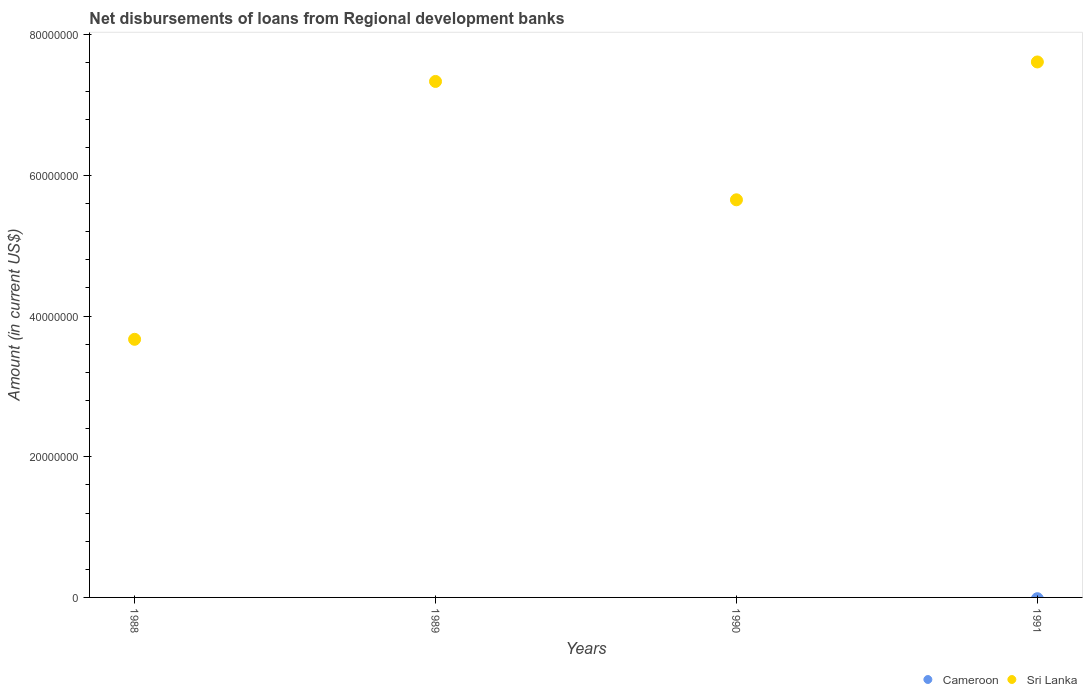What is the amount of disbursements of loans from regional development banks in Sri Lanka in 1990?
Provide a short and direct response. 5.65e+07. Across all years, what is the maximum amount of disbursements of loans from regional development banks in Sri Lanka?
Your answer should be very brief. 7.61e+07. Across all years, what is the minimum amount of disbursements of loans from regional development banks in Sri Lanka?
Your answer should be compact. 3.67e+07. What is the total amount of disbursements of loans from regional development banks in Sri Lanka in the graph?
Provide a succinct answer. 2.43e+08. What is the difference between the amount of disbursements of loans from regional development banks in Sri Lanka in 1989 and that in 1991?
Keep it short and to the point. -2.77e+06. What is the difference between the amount of disbursements of loans from regional development banks in Sri Lanka in 1988 and the amount of disbursements of loans from regional development banks in Cameroon in 1989?
Provide a short and direct response. 3.67e+07. What is the average amount of disbursements of loans from regional development banks in Sri Lanka per year?
Ensure brevity in your answer.  6.07e+07. What is the ratio of the amount of disbursements of loans from regional development banks in Sri Lanka in 1989 to that in 1991?
Offer a terse response. 0.96. Is the amount of disbursements of loans from regional development banks in Sri Lanka in 1990 less than that in 1991?
Offer a very short reply. Yes. What is the difference between the highest and the second highest amount of disbursements of loans from regional development banks in Sri Lanka?
Keep it short and to the point. 2.77e+06. What is the difference between the highest and the lowest amount of disbursements of loans from regional development banks in Sri Lanka?
Keep it short and to the point. 3.94e+07. In how many years, is the amount of disbursements of loans from regional development banks in Sri Lanka greater than the average amount of disbursements of loans from regional development banks in Sri Lanka taken over all years?
Provide a succinct answer. 2. Is the sum of the amount of disbursements of loans from regional development banks in Sri Lanka in 1988 and 1989 greater than the maximum amount of disbursements of loans from regional development banks in Cameroon across all years?
Provide a short and direct response. Yes. Is the amount of disbursements of loans from regional development banks in Cameroon strictly greater than the amount of disbursements of loans from regional development banks in Sri Lanka over the years?
Your answer should be very brief. No. How many dotlines are there?
Your answer should be very brief. 1. How many years are there in the graph?
Your answer should be compact. 4. What is the difference between two consecutive major ticks on the Y-axis?
Give a very brief answer. 2.00e+07. Does the graph contain grids?
Provide a short and direct response. No. Where does the legend appear in the graph?
Make the answer very short. Bottom right. How are the legend labels stacked?
Keep it short and to the point. Horizontal. What is the title of the graph?
Give a very brief answer. Net disbursements of loans from Regional development banks. What is the label or title of the X-axis?
Give a very brief answer. Years. What is the label or title of the Y-axis?
Your answer should be compact. Amount (in current US$). What is the Amount (in current US$) of Sri Lanka in 1988?
Give a very brief answer. 3.67e+07. What is the Amount (in current US$) of Cameroon in 1989?
Offer a terse response. 0. What is the Amount (in current US$) in Sri Lanka in 1989?
Ensure brevity in your answer.  7.34e+07. What is the Amount (in current US$) in Cameroon in 1990?
Provide a short and direct response. 0. What is the Amount (in current US$) of Sri Lanka in 1990?
Provide a short and direct response. 5.65e+07. What is the Amount (in current US$) in Sri Lanka in 1991?
Offer a very short reply. 7.61e+07. Across all years, what is the maximum Amount (in current US$) in Sri Lanka?
Your response must be concise. 7.61e+07. Across all years, what is the minimum Amount (in current US$) of Sri Lanka?
Offer a terse response. 3.67e+07. What is the total Amount (in current US$) of Cameroon in the graph?
Your response must be concise. 0. What is the total Amount (in current US$) of Sri Lanka in the graph?
Give a very brief answer. 2.43e+08. What is the difference between the Amount (in current US$) in Sri Lanka in 1988 and that in 1989?
Offer a very short reply. -3.67e+07. What is the difference between the Amount (in current US$) in Sri Lanka in 1988 and that in 1990?
Make the answer very short. -1.98e+07. What is the difference between the Amount (in current US$) in Sri Lanka in 1988 and that in 1991?
Provide a succinct answer. -3.94e+07. What is the difference between the Amount (in current US$) in Sri Lanka in 1989 and that in 1990?
Provide a succinct answer. 1.68e+07. What is the difference between the Amount (in current US$) of Sri Lanka in 1989 and that in 1991?
Offer a terse response. -2.77e+06. What is the difference between the Amount (in current US$) of Sri Lanka in 1990 and that in 1991?
Provide a short and direct response. -1.96e+07. What is the average Amount (in current US$) in Sri Lanka per year?
Provide a short and direct response. 6.07e+07. What is the ratio of the Amount (in current US$) in Sri Lanka in 1988 to that in 1989?
Your answer should be compact. 0.5. What is the ratio of the Amount (in current US$) in Sri Lanka in 1988 to that in 1990?
Ensure brevity in your answer.  0.65. What is the ratio of the Amount (in current US$) of Sri Lanka in 1988 to that in 1991?
Offer a very short reply. 0.48. What is the ratio of the Amount (in current US$) of Sri Lanka in 1989 to that in 1990?
Keep it short and to the point. 1.3. What is the ratio of the Amount (in current US$) of Sri Lanka in 1989 to that in 1991?
Provide a succinct answer. 0.96. What is the ratio of the Amount (in current US$) of Sri Lanka in 1990 to that in 1991?
Ensure brevity in your answer.  0.74. What is the difference between the highest and the second highest Amount (in current US$) of Sri Lanka?
Your answer should be compact. 2.77e+06. What is the difference between the highest and the lowest Amount (in current US$) of Sri Lanka?
Provide a short and direct response. 3.94e+07. 